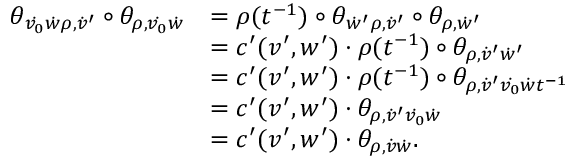<formula> <loc_0><loc_0><loc_500><loc_500>\begin{array} { r l } { \theta _ { \dot { v _ { 0 } } \dot { w } \rho , \dot { v } ^ { \prime } } \circ \theta _ { \rho , \dot { v _ { 0 } } \dot { w } } } & { = \rho ( t ^ { - 1 } ) \circ \theta _ { \dot { w } ^ { \prime } \rho , \dot { v } ^ { \prime } } \circ \theta _ { \rho , \dot { w } ^ { \prime } } } \\ & { = c ^ { \prime } ( v ^ { \prime } , w ^ { \prime } ) \cdot \rho ( t ^ { - 1 } ) \circ \theta _ { \rho , \dot { v } ^ { \prime } \dot { w } ^ { \prime } } } \\ & { = c ^ { \prime } ( v ^ { \prime } , w ^ { \prime } ) \cdot \rho ( t ^ { - 1 } ) \circ \theta _ { \rho , \dot { v } ^ { \prime } \dot { v _ { 0 } } \dot { w } t ^ { - 1 } } } \\ & { = c ^ { \prime } ( v ^ { \prime } , w ^ { \prime } ) \cdot \theta _ { \rho , \dot { v } ^ { \prime } \dot { v _ { 0 } } \dot { w } } } \\ & { = c ^ { \prime } ( v ^ { \prime } , w ^ { \prime } ) \cdot \theta _ { \rho , \dot { v } \dot { w } } . } \end{array}</formula> 